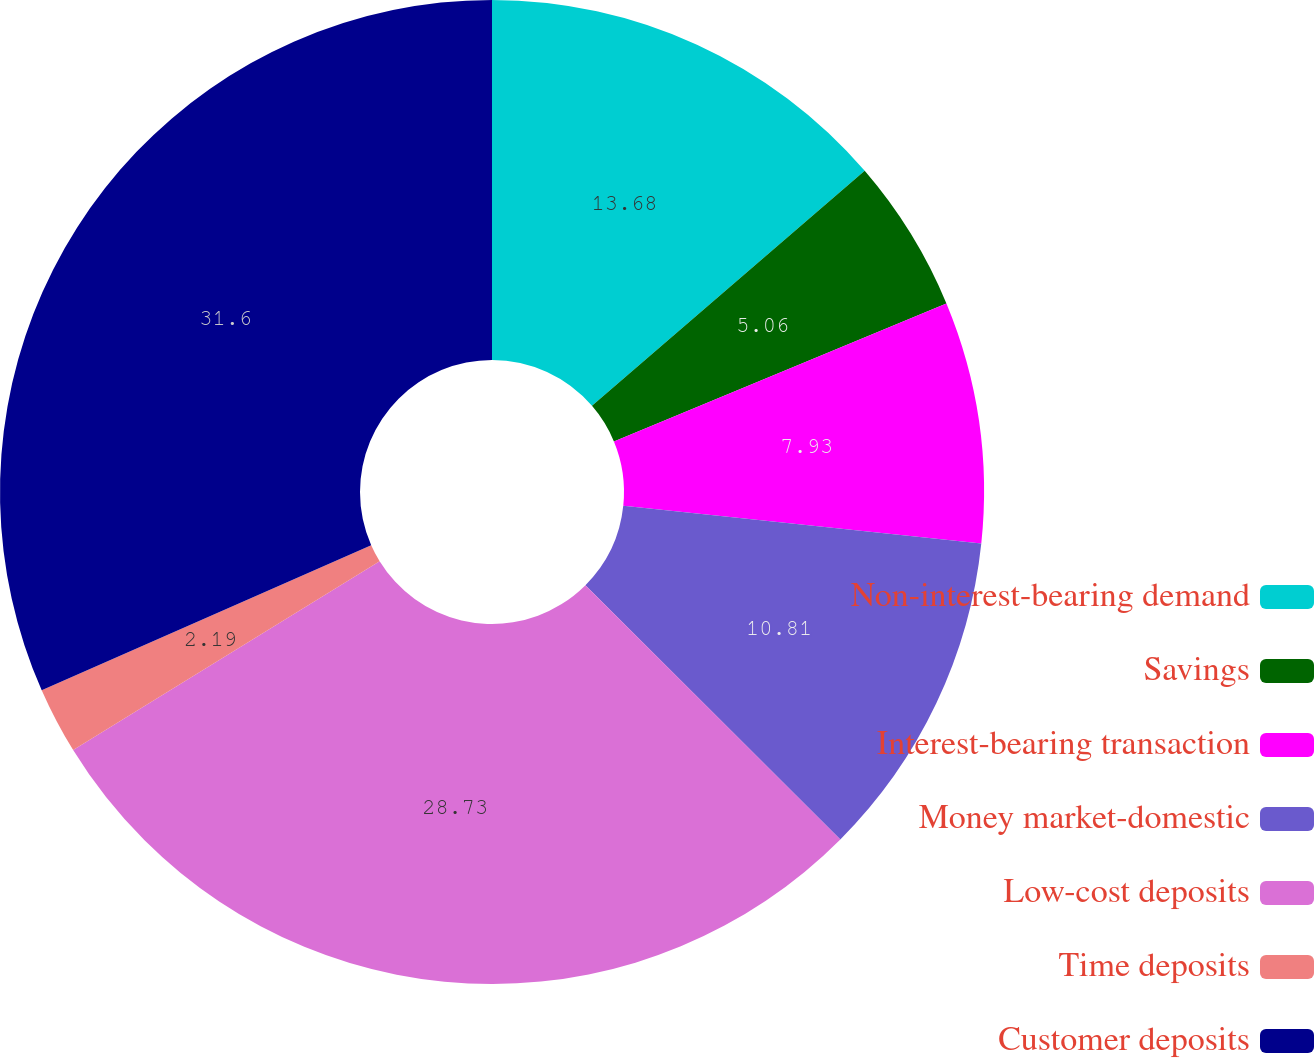Convert chart. <chart><loc_0><loc_0><loc_500><loc_500><pie_chart><fcel>Non-interest-bearing demand<fcel>Savings<fcel>Interest-bearing transaction<fcel>Money market-domestic<fcel>Low-cost deposits<fcel>Time deposits<fcel>Customer deposits<nl><fcel>13.68%<fcel>5.06%<fcel>7.93%<fcel>10.81%<fcel>28.73%<fcel>2.19%<fcel>31.6%<nl></chart> 